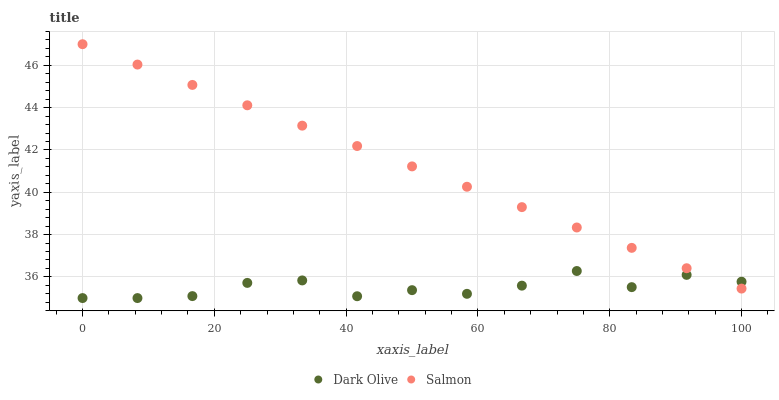Does Dark Olive have the minimum area under the curve?
Answer yes or no. Yes. Does Salmon have the maximum area under the curve?
Answer yes or no. Yes. Does Salmon have the minimum area under the curve?
Answer yes or no. No. Is Salmon the smoothest?
Answer yes or no. Yes. Is Dark Olive the roughest?
Answer yes or no. Yes. Is Salmon the roughest?
Answer yes or no. No. Does Dark Olive have the lowest value?
Answer yes or no. Yes. Does Salmon have the lowest value?
Answer yes or no. No. Does Salmon have the highest value?
Answer yes or no. Yes. Does Salmon intersect Dark Olive?
Answer yes or no. Yes. Is Salmon less than Dark Olive?
Answer yes or no. No. Is Salmon greater than Dark Olive?
Answer yes or no. No. 